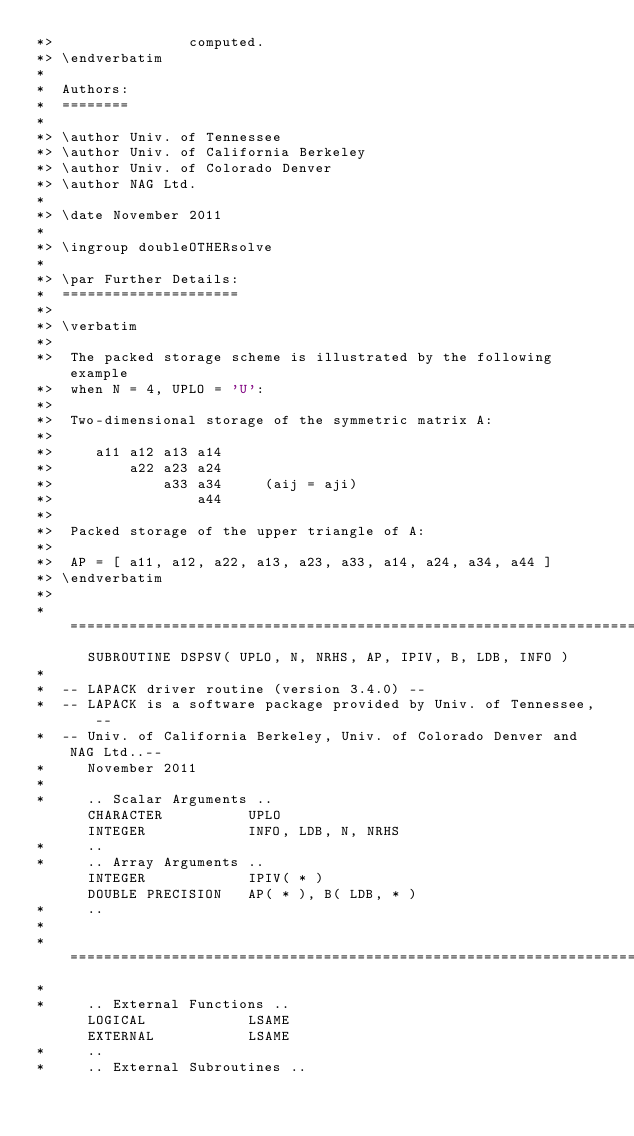Convert code to text. <code><loc_0><loc_0><loc_500><loc_500><_FORTRAN_>*>                computed.
*> \endverbatim
*
*  Authors:
*  ========
*
*> \author Univ. of Tennessee 
*> \author Univ. of California Berkeley 
*> \author Univ. of Colorado Denver 
*> \author NAG Ltd. 
*
*> \date November 2011
*
*> \ingroup doubleOTHERsolve
*
*> \par Further Details:
*  =====================
*>
*> \verbatim
*>
*>  The packed storage scheme is illustrated by the following example
*>  when N = 4, UPLO = 'U':
*>
*>  Two-dimensional storage of the symmetric matrix A:
*>
*>     a11 a12 a13 a14
*>         a22 a23 a24
*>             a33 a34     (aij = aji)
*>                 a44
*>
*>  Packed storage of the upper triangle of A:
*>
*>  AP = [ a11, a12, a22, a13, a23, a33, a14, a24, a34, a44 ]
*> \endverbatim
*>
*  =====================================================================
      SUBROUTINE DSPSV( UPLO, N, NRHS, AP, IPIV, B, LDB, INFO )
*
*  -- LAPACK driver routine (version 3.4.0) --
*  -- LAPACK is a software package provided by Univ. of Tennessee,    --
*  -- Univ. of California Berkeley, Univ. of Colorado Denver and NAG Ltd..--
*     November 2011
*
*     .. Scalar Arguments ..
      CHARACTER          UPLO
      INTEGER            INFO, LDB, N, NRHS
*     ..
*     .. Array Arguments ..
      INTEGER            IPIV( * )
      DOUBLE PRECISION   AP( * ), B( LDB, * )
*     ..
*
*  =====================================================================
*
*     .. External Functions ..
      LOGICAL            LSAME
      EXTERNAL           LSAME
*     ..
*     .. External Subroutines ..</code> 